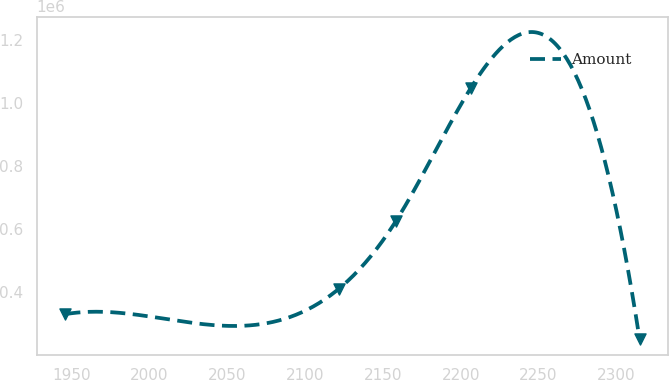Convert chart to OTSL. <chart><loc_0><loc_0><loc_500><loc_500><line_chart><ecel><fcel>Amount<nl><fcel>1946.3<fcel>329533<nl><fcel>2121.64<fcel>409353<nl><fcel>2158.5<fcel>625626<nl><fcel>2206.54<fcel>1.04791e+06<nl><fcel>2314.89<fcel>249713<nl></chart> 